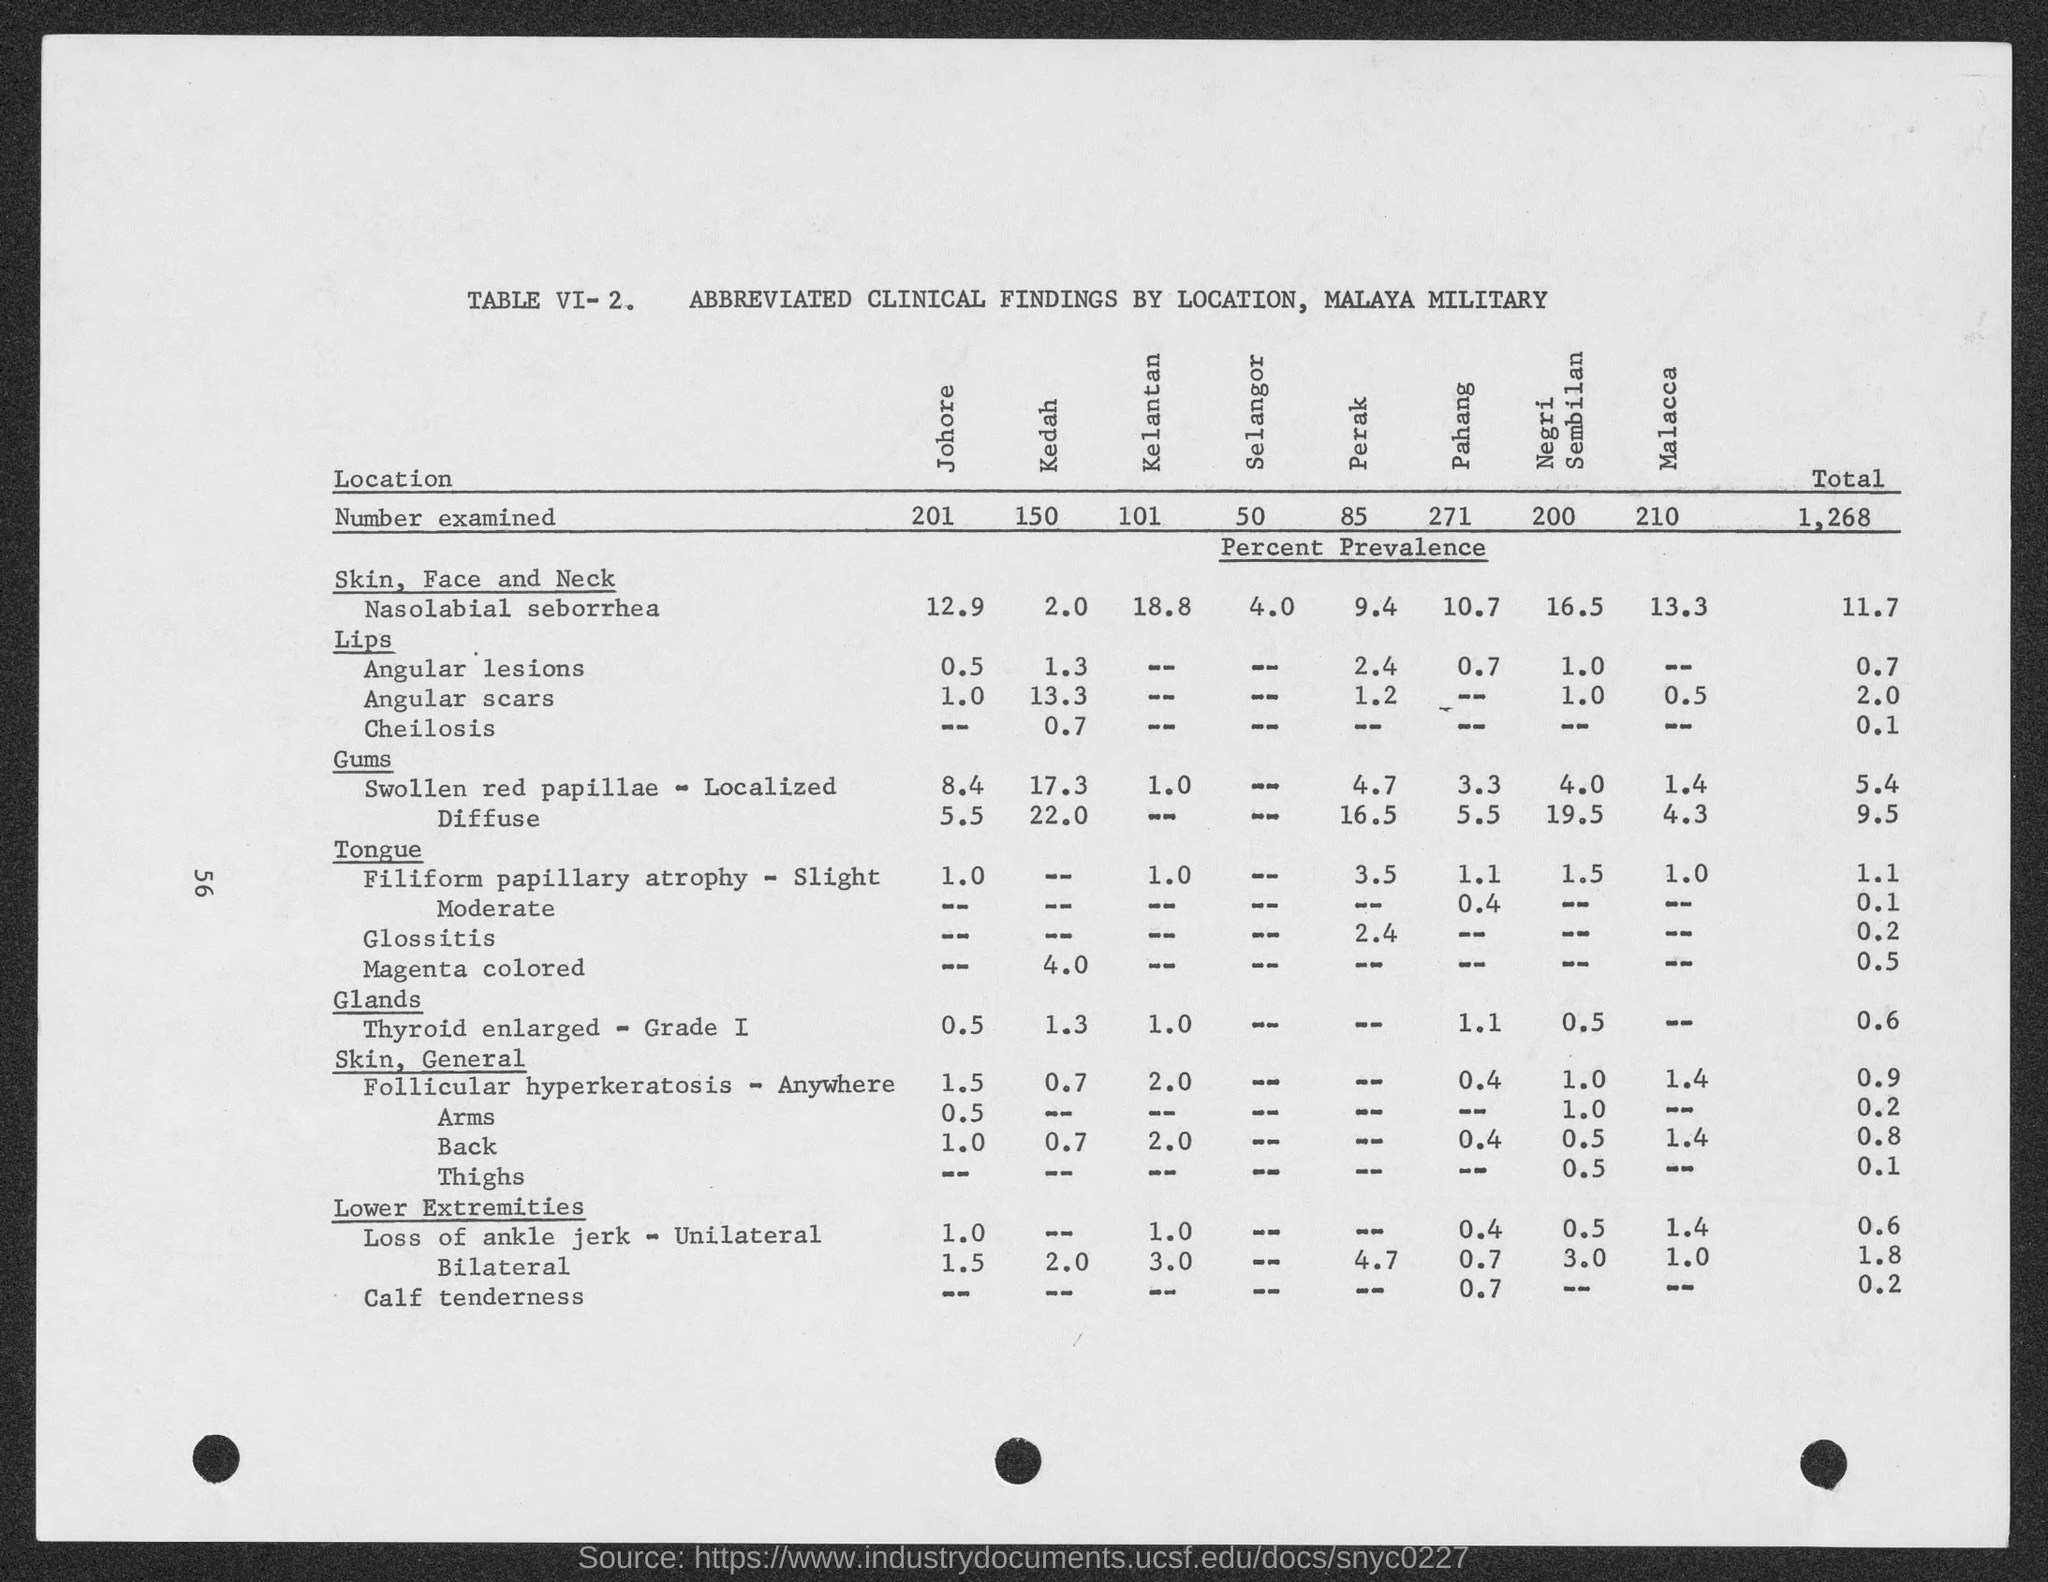What is the table no. ?
Provide a short and direct response. VI-2. What is the total number examined ?
Provide a short and direct response. 1,268. What is the number examined in johore?
Provide a succinct answer. 201. What is the number examined in kedah?
Your response must be concise. 150. What is the number examined in kelantan ?
Give a very brief answer. 101. What is the number examined in selangor ?
Keep it short and to the point. 50. What is the number examined in perak?
Make the answer very short. 85. What is the number examined in pahang ?
Your answer should be very brief. 271. What is the number examined in negri sembilan ?
Your answer should be very brief. 200. What is the number examined in malacca ?
Offer a terse response. 210. 